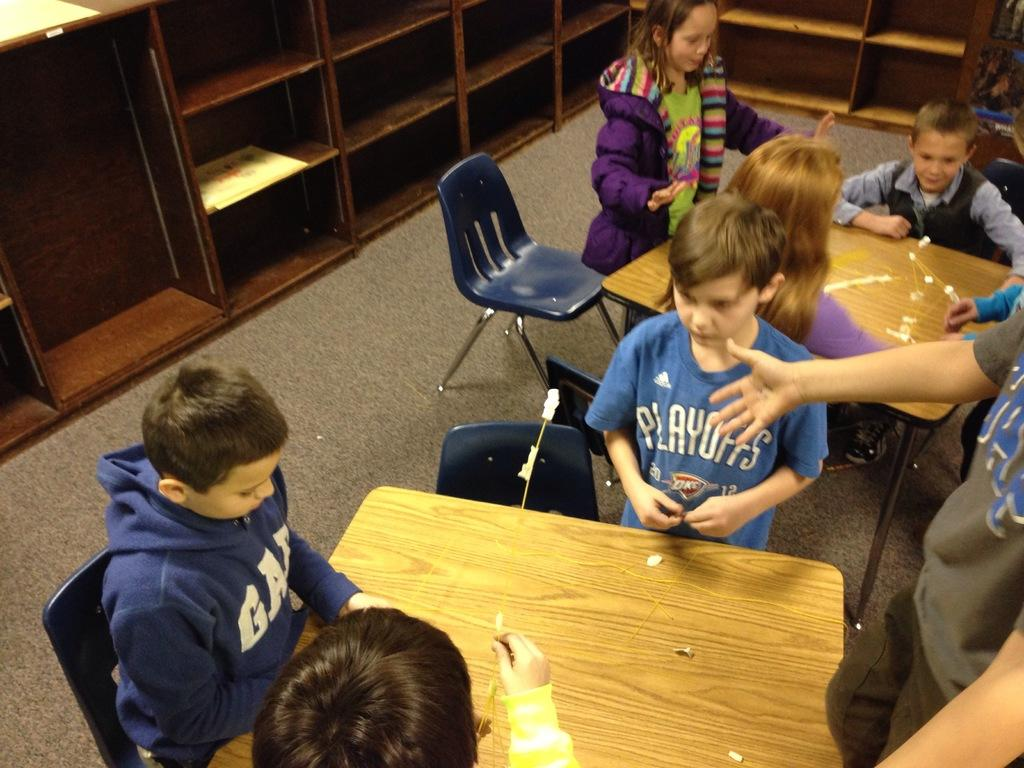Who is present in the image? There are children in the image. What are the children doing in the image? The children are playing. What type of attraction can be seen in the background of the image? There is no attraction visible in the background of the image. What is the train doing in the image? There is no train present in the image. 